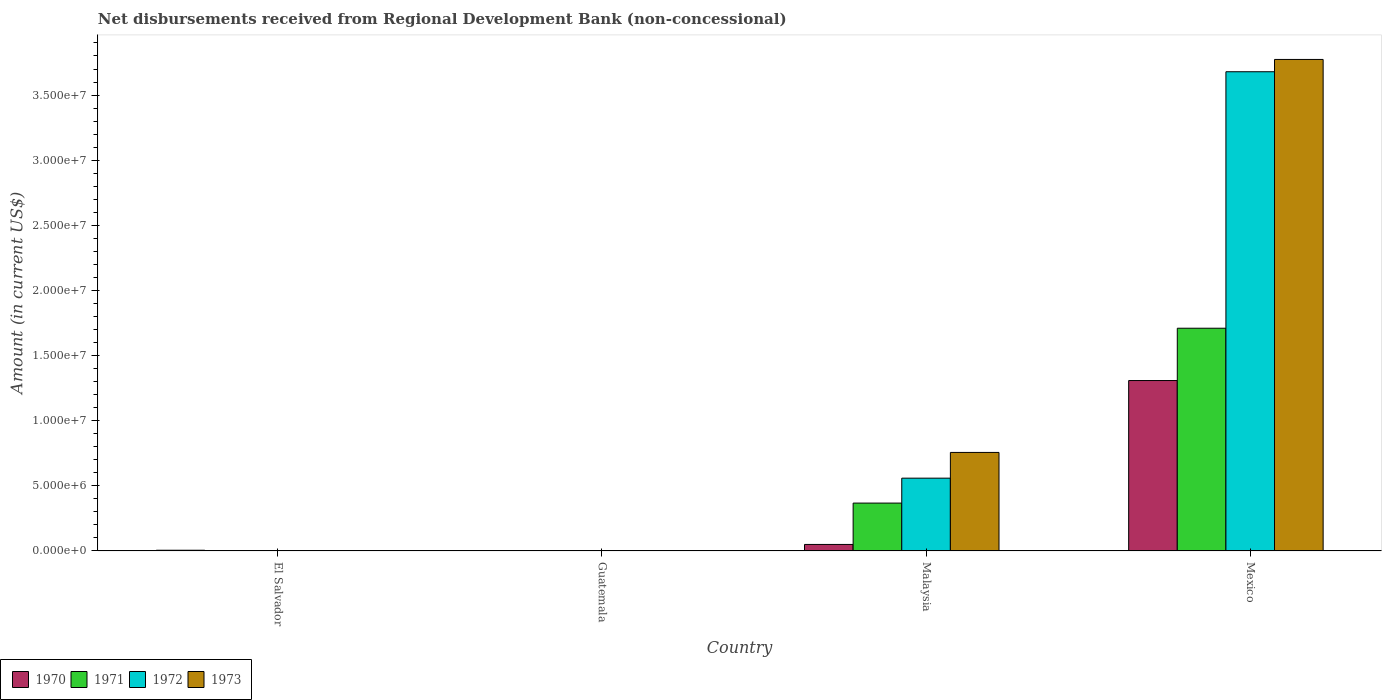How many different coloured bars are there?
Your answer should be very brief. 4. Are the number of bars on each tick of the X-axis equal?
Offer a terse response. No. How many bars are there on the 1st tick from the left?
Offer a very short reply. 1. What is the label of the 2nd group of bars from the left?
Your response must be concise. Guatemala. In how many cases, is the number of bars for a given country not equal to the number of legend labels?
Your response must be concise. 2. What is the amount of disbursements received from Regional Development Bank in 1971 in El Salvador?
Give a very brief answer. 0. Across all countries, what is the maximum amount of disbursements received from Regional Development Bank in 1973?
Your answer should be compact. 3.77e+07. Across all countries, what is the minimum amount of disbursements received from Regional Development Bank in 1971?
Keep it short and to the point. 0. What is the total amount of disbursements received from Regional Development Bank in 1971 in the graph?
Give a very brief answer. 2.08e+07. What is the difference between the amount of disbursements received from Regional Development Bank in 1970 in El Salvador and that in Malaysia?
Ensure brevity in your answer.  -4.45e+05. What is the difference between the amount of disbursements received from Regional Development Bank in 1970 in Mexico and the amount of disbursements received from Regional Development Bank in 1971 in Malaysia?
Offer a terse response. 9.41e+06. What is the average amount of disbursements received from Regional Development Bank in 1970 per country?
Give a very brief answer. 3.41e+06. What is the difference between the amount of disbursements received from Regional Development Bank of/in 1971 and amount of disbursements received from Regional Development Bank of/in 1972 in Mexico?
Keep it short and to the point. -1.97e+07. What is the ratio of the amount of disbursements received from Regional Development Bank in 1970 in El Salvador to that in Mexico?
Give a very brief answer. 0. What is the difference between the highest and the second highest amount of disbursements received from Regional Development Bank in 1970?
Give a very brief answer. 1.26e+07. What is the difference between the highest and the lowest amount of disbursements received from Regional Development Bank in 1970?
Offer a very short reply. 1.31e+07. Is the sum of the amount of disbursements received from Regional Development Bank in 1971 in Malaysia and Mexico greater than the maximum amount of disbursements received from Regional Development Bank in 1970 across all countries?
Keep it short and to the point. Yes. Are the values on the major ticks of Y-axis written in scientific E-notation?
Provide a succinct answer. Yes. Does the graph contain any zero values?
Ensure brevity in your answer.  Yes. Does the graph contain grids?
Make the answer very short. No. How many legend labels are there?
Offer a very short reply. 4. How are the legend labels stacked?
Your response must be concise. Horizontal. What is the title of the graph?
Ensure brevity in your answer.  Net disbursements received from Regional Development Bank (non-concessional). What is the label or title of the Y-axis?
Ensure brevity in your answer.  Amount (in current US$). What is the Amount (in current US$) in 1970 in El Salvador?
Your answer should be compact. 5.70e+04. What is the Amount (in current US$) in 1972 in El Salvador?
Keep it short and to the point. 0. What is the Amount (in current US$) of 1973 in El Salvador?
Ensure brevity in your answer.  0. What is the Amount (in current US$) of 1970 in Guatemala?
Your answer should be compact. 0. What is the Amount (in current US$) of 1971 in Guatemala?
Your response must be concise. 0. What is the Amount (in current US$) in 1973 in Guatemala?
Make the answer very short. 0. What is the Amount (in current US$) in 1970 in Malaysia?
Your answer should be very brief. 5.02e+05. What is the Amount (in current US$) of 1971 in Malaysia?
Make the answer very short. 3.68e+06. What is the Amount (in current US$) in 1972 in Malaysia?
Provide a short and direct response. 5.59e+06. What is the Amount (in current US$) in 1973 in Malaysia?
Offer a very short reply. 7.57e+06. What is the Amount (in current US$) of 1970 in Mexico?
Your answer should be very brief. 1.31e+07. What is the Amount (in current US$) of 1971 in Mexico?
Offer a terse response. 1.71e+07. What is the Amount (in current US$) in 1972 in Mexico?
Your response must be concise. 3.68e+07. What is the Amount (in current US$) of 1973 in Mexico?
Your answer should be compact. 3.77e+07. Across all countries, what is the maximum Amount (in current US$) in 1970?
Make the answer very short. 1.31e+07. Across all countries, what is the maximum Amount (in current US$) in 1971?
Make the answer very short. 1.71e+07. Across all countries, what is the maximum Amount (in current US$) of 1972?
Give a very brief answer. 3.68e+07. Across all countries, what is the maximum Amount (in current US$) of 1973?
Your answer should be compact. 3.77e+07. Across all countries, what is the minimum Amount (in current US$) in 1970?
Offer a terse response. 0. What is the total Amount (in current US$) in 1970 in the graph?
Provide a succinct answer. 1.36e+07. What is the total Amount (in current US$) in 1971 in the graph?
Your answer should be compact. 2.08e+07. What is the total Amount (in current US$) in 1972 in the graph?
Your response must be concise. 4.24e+07. What is the total Amount (in current US$) in 1973 in the graph?
Your response must be concise. 4.53e+07. What is the difference between the Amount (in current US$) in 1970 in El Salvador and that in Malaysia?
Offer a terse response. -4.45e+05. What is the difference between the Amount (in current US$) in 1970 in El Salvador and that in Mexico?
Your response must be concise. -1.30e+07. What is the difference between the Amount (in current US$) of 1970 in Malaysia and that in Mexico?
Give a very brief answer. -1.26e+07. What is the difference between the Amount (in current US$) of 1971 in Malaysia and that in Mexico?
Ensure brevity in your answer.  -1.34e+07. What is the difference between the Amount (in current US$) of 1972 in Malaysia and that in Mexico?
Offer a terse response. -3.12e+07. What is the difference between the Amount (in current US$) in 1973 in Malaysia and that in Mexico?
Make the answer very short. -3.02e+07. What is the difference between the Amount (in current US$) in 1970 in El Salvador and the Amount (in current US$) in 1971 in Malaysia?
Ensure brevity in your answer.  -3.62e+06. What is the difference between the Amount (in current US$) in 1970 in El Salvador and the Amount (in current US$) in 1972 in Malaysia?
Your answer should be very brief. -5.53e+06. What is the difference between the Amount (in current US$) in 1970 in El Salvador and the Amount (in current US$) in 1973 in Malaysia?
Your response must be concise. -7.51e+06. What is the difference between the Amount (in current US$) of 1970 in El Salvador and the Amount (in current US$) of 1971 in Mexico?
Your response must be concise. -1.70e+07. What is the difference between the Amount (in current US$) in 1970 in El Salvador and the Amount (in current US$) in 1972 in Mexico?
Give a very brief answer. -3.67e+07. What is the difference between the Amount (in current US$) of 1970 in El Salvador and the Amount (in current US$) of 1973 in Mexico?
Give a very brief answer. -3.77e+07. What is the difference between the Amount (in current US$) of 1970 in Malaysia and the Amount (in current US$) of 1971 in Mexico?
Make the answer very short. -1.66e+07. What is the difference between the Amount (in current US$) in 1970 in Malaysia and the Amount (in current US$) in 1972 in Mexico?
Give a very brief answer. -3.63e+07. What is the difference between the Amount (in current US$) of 1970 in Malaysia and the Amount (in current US$) of 1973 in Mexico?
Keep it short and to the point. -3.72e+07. What is the difference between the Amount (in current US$) in 1971 in Malaysia and the Amount (in current US$) in 1972 in Mexico?
Your answer should be very brief. -3.31e+07. What is the difference between the Amount (in current US$) of 1971 in Malaysia and the Amount (in current US$) of 1973 in Mexico?
Your response must be concise. -3.41e+07. What is the difference between the Amount (in current US$) in 1972 in Malaysia and the Amount (in current US$) in 1973 in Mexico?
Offer a terse response. -3.21e+07. What is the average Amount (in current US$) of 1970 per country?
Offer a terse response. 3.41e+06. What is the average Amount (in current US$) of 1971 per country?
Your answer should be compact. 5.19e+06. What is the average Amount (in current US$) in 1972 per country?
Offer a very short reply. 1.06e+07. What is the average Amount (in current US$) in 1973 per country?
Provide a succinct answer. 1.13e+07. What is the difference between the Amount (in current US$) of 1970 and Amount (in current US$) of 1971 in Malaysia?
Keep it short and to the point. -3.18e+06. What is the difference between the Amount (in current US$) in 1970 and Amount (in current US$) in 1972 in Malaysia?
Your response must be concise. -5.09e+06. What is the difference between the Amount (in current US$) of 1970 and Amount (in current US$) of 1973 in Malaysia?
Provide a short and direct response. -7.06e+06. What is the difference between the Amount (in current US$) in 1971 and Amount (in current US$) in 1972 in Malaysia?
Offer a terse response. -1.91e+06. What is the difference between the Amount (in current US$) in 1971 and Amount (in current US$) in 1973 in Malaysia?
Offer a very short reply. -3.89e+06. What is the difference between the Amount (in current US$) of 1972 and Amount (in current US$) of 1973 in Malaysia?
Ensure brevity in your answer.  -1.98e+06. What is the difference between the Amount (in current US$) in 1970 and Amount (in current US$) in 1971 in Mexico?
Give a very brief answer. -4.02e+06. What is the difference between the Amount (in current US$) of 1970 and Amount (in current US$) of 1972 in Mexico?
Your response must be concise. -2.37e+07. What is the difference between the Amount (in current US$) in 1970 and Amount (in current US$) in 1973 in Mexico?
Offer a very short reply. -2.46e+07. What is the difference between the Amount (in current US$) in 1971 and Amount (in current US$) in 1972 in Mexico?
Ensure brevity in your answer.  -1.97e+07. What is the difference between the Amount (in current US$) of 1971 and Amount (in current US$) of 1973 in Mexico?
Your answer should be very brief. -2.06e+07. What is the difference between the Amount (in current US$) of 1972 and Amount (in current US$) of 1973 in Mexico?
Your response must be concise. -9.43e+05. What is the ratio of the Amount (in current US$) in 1970 in El Salvador to that in Malaysia?
Give a very brief answer. 0.11. What is the ratio of the Amount (in current US$) in 1970 in El Salvador to that in Mexico?
Provide a short and direct response. 0. What is the ratio of the Amount (in current US$) of 1970 in Malaysia to that in Mexico?
Your response must be concise. 0.04. What is the ratio of the Amount (in current US$) of 1971 in Malaysia to that in Mexico?
Offer a very short reply. 0.21. What is the ratio of the Amount (in current US$) of 1972 in Malaysia to that in Mexico?
Provide a succinct answer. 0.15. What is the ratio of the Amount (in current US$) in 1973 in Malaysia to that in Mexico?
Your answer should be compact. 0.2. What is the difference between the highest and the second highest Amount (in current US$) in 1970?
Keep it short and to the point. 1.26e+07. What is the difference between the highest and the lowest Amount (in current US$) of 1970?
Offer a very short reply. 1.31e+07. What is the difference between the highest and the lowest Amount (in current US$) in 1971?
Your answer should be very brief. 1.71e+07. What is the difference between the highest and the lowest Amount (in current US$) in 1972?
Make the answer very short. 3.68e+07. What is the difference between the highest and the lowest Amount (in current US$) in 1973?
Give a very brief answer. 3.77e+07. 